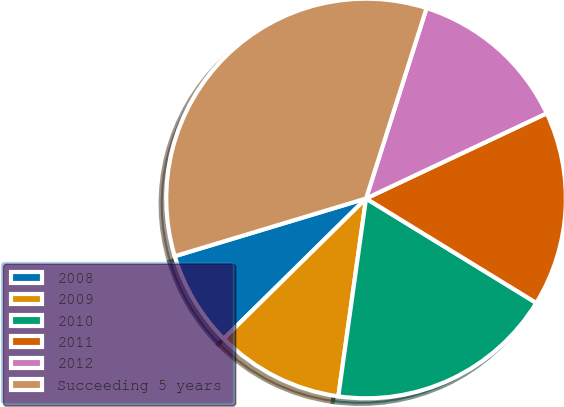Convert chart. <chart><loc_0><loc_0><loc_500><loc_500><pie_chart><fcel>2008<fcel>2009<fcel>2010<fcel>2011<fcel>2012<fcel>Succeeding 5 years<nl><fcel>7.72%<fcel>10.4%<fcel>18.46%<fcel>15.77%<fcel>13.09%<fcel>34.56%<nl></chart> 